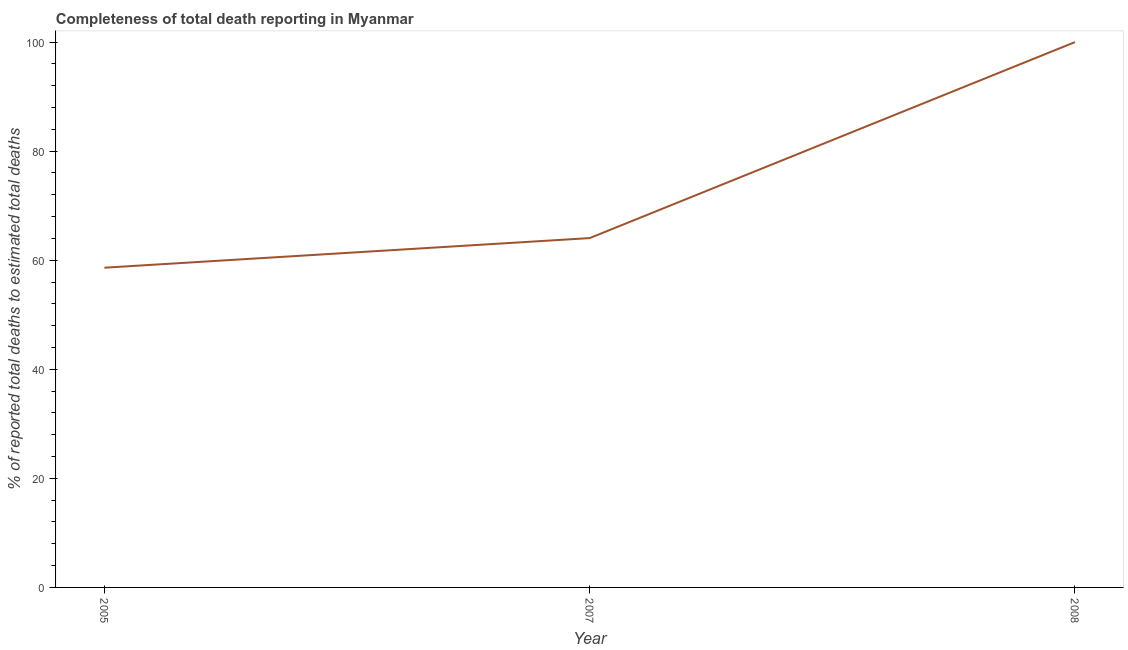What is the completeness of total death reports in 2005?
Your response must be concise. 58.63. Across all years, what is the minimum completeness of total death reports?
Offer a very short reply. 58.63. What is the sum of the completeness of total death reports?
Give a very brief answer. 222.69. What is the difference between the completeness of total death reports in 2007 and 2008?
Your answer should be very brief. -35.94. What is the average completeness of total death reports per year?
Your response must be concise. 74.23. What is the median completeness of total death reports?
Ensure brevity in your answer.  64.06. In how many years, is the completeness of total death reports greater than 48 %?
Your answer should be compact. 3. Do a majority of the years between 2005 and 2007 (inclusive) have completeness of total death reports greater than 96 %?
Keep it short and to the point. No. What is the ratio of the completeness of total death reports in 2005 to that in 2007?
Your answer should be very brief. 0.92. Is the difference between the completeness of total death reports in 2005 and 2008 greater than the difference between any two years?
Ensure brevity in your answer.  Yes. What is the difference between the highest and the second highest completeness of total death reports?
Ensure brevity in your answer.  35.94. Is the sum of the completeness of total death reports in 2005 and 2008 greater than the maximum completeness of total death reports across all years?
Make the answer very short. Yes. What is the difference between the highest and the lowest completeness of total death reports?
Your response must be concise. 41.37. How many years are there in the graph?
Provide a succinct answer. 3. Are the values on the major ticks of Y-axis written in scientific E-notation?
Make the answer very short. No. What is the title of the graph?
Ensure brevity in your answer.  Completeness of total death reporting in Myanmar. What is the label or title of the X-axis?
Make the answer very short. Year. What is the label or title of the Y-axis?
Give a very brief answer. % of reported total deaths to estimated total deaths. What is the % of reported total deaths to estimated total deaths in 2005?
Offer a terse response. 58.63. What is the % of reported total deaths to estimated total deaths in 2007?
Offer a terse response. 64.06. What is the % of reported total deaths to estimated total deaths of 2008?
Provide a succinct answer. 100. What is the difference between the % of reported total deaths to estimated total deaths in 2005 and 2007?
Provide a short and direct response. -5.43. What is the difference between the % of reported total deaths to estimated total deaths in 2005 and 2008?
Offer a very short reply. -41.37. What is the difference between the % of reported total deaths to estimated total deaths in 2007 and 2008?
Offer a very short reply. -35.94. What is the ratio of the % of reported total deaths to estimated total deaths in 2005 to that in 2007?
Provide a succinct answer. 0.92. What is the ratio of the % of reported total deaths to estimated total deaths in 2005 to that in 2008?
Offer a terse response. 0.59. What is the ratio of the % of reported total deaths to estimated total deaths in 2007 to that in 2008?
Your answer should be compact. 0.64. 